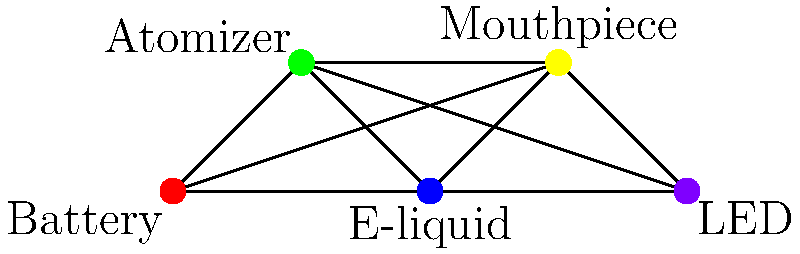In optimal packaging configuration for e-cigarette components, we need to ensure that components that interfere with each other are not placed in the same compartment. The graph represents the interference between components, where each vertex is a component and each edge represents interference. What is the chromatic number of this graph, representing the minimum number of compartments needed for optimal packaging? To determine the chromatic number of the graph, we need to follow these steps:

1. Identify the vertices: Battery, Atomizer, E-liquid, Mouthpiece, and LED.

2. Analyze the graph structure:
   - It's a complete graph (K5) where every vertex is connected to every other vertex.

3. Recall the chromatic number for complete graphs:
   - For a complete graph with n vertices, the chromatic number is always n.
   - This is because each vertex must have a different color (or in this case, be in a different compartment) from all others.

4. Count the number of vertices:
   - There are 5 vertices in this graph.

5. Conclude:
   - Since this is a complete graph with 5 vertices (K5), the chromatic number is 5.

Therefore, we need a minimum of 5 compartments to package these e-cigarette components optimally, ensuring that no interfering components are placed together.
Answer: 5 